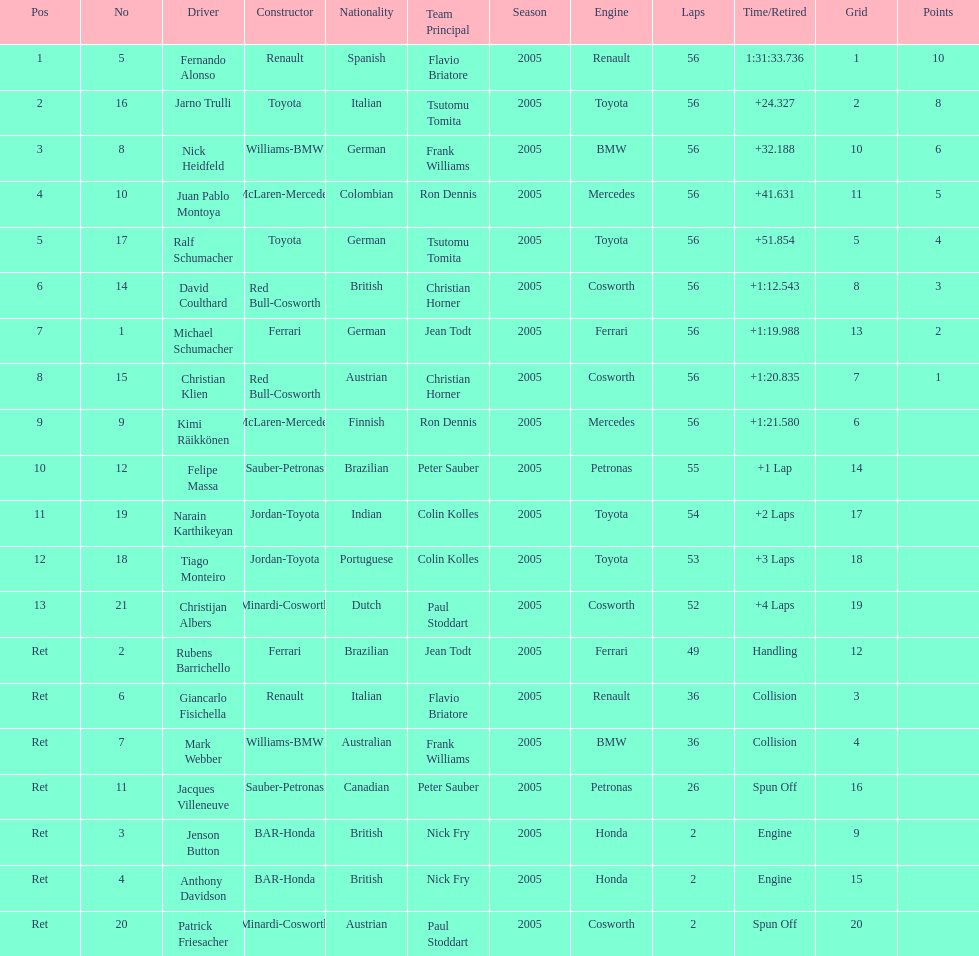Who finished before nick heidfeld? Jarno Trulli. 